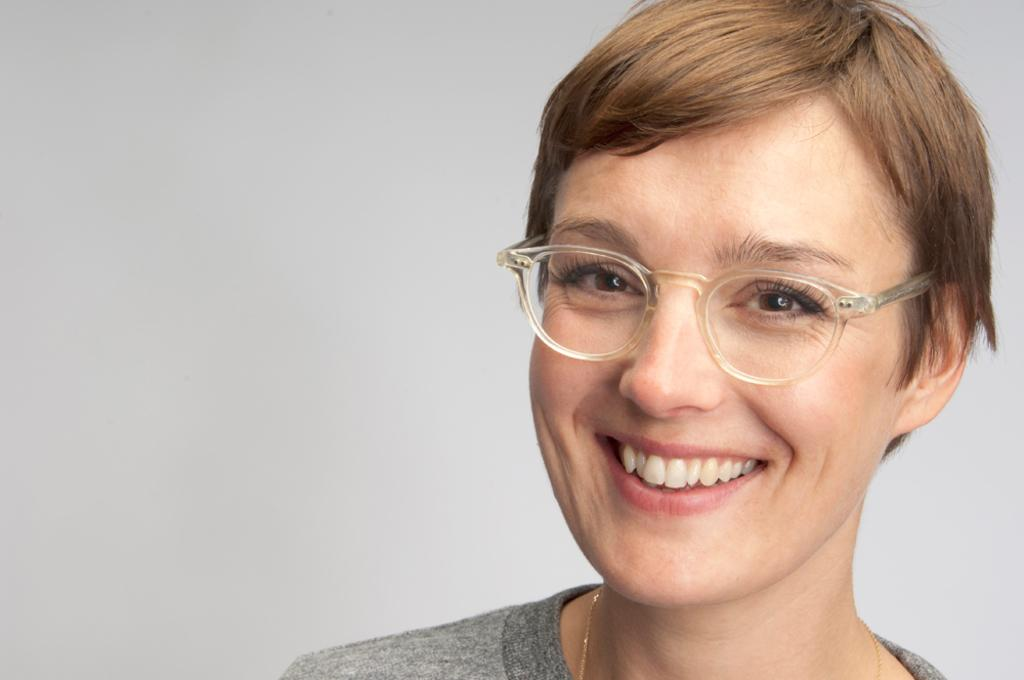Who is the main subject in the image? There is a woman in the image. Where is the woman located in the image? The woman is in the front of the image. What is the woman's facial expression in the image? The woman is smiling. What color is the ladybug on the woman's shoulder in the image? There is no ladybug present on the woman's shoulder in the image. 